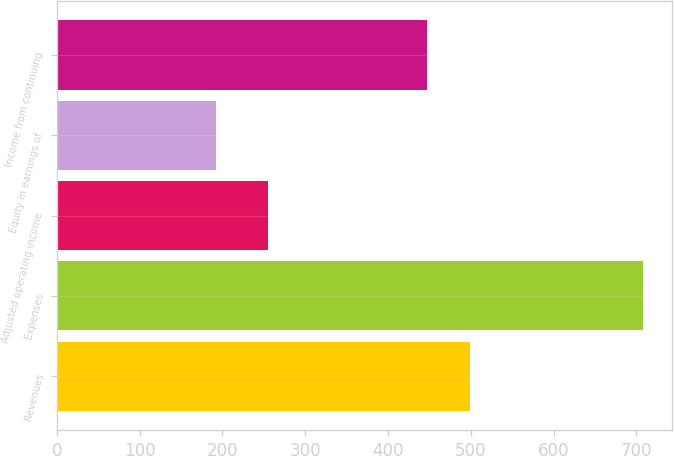<chart> <loc_0><loc_0><loc_500><loc_500><bar_chart><fcel>Revenues<fcel>Expenses<fcel>Adjusted operating income<fcel>Equity in earnings of<fcel>Income from continuing<nl><fcel>498.6<fcel>708<fcel>255<fcel>192<fcel>447<nl></chart> 